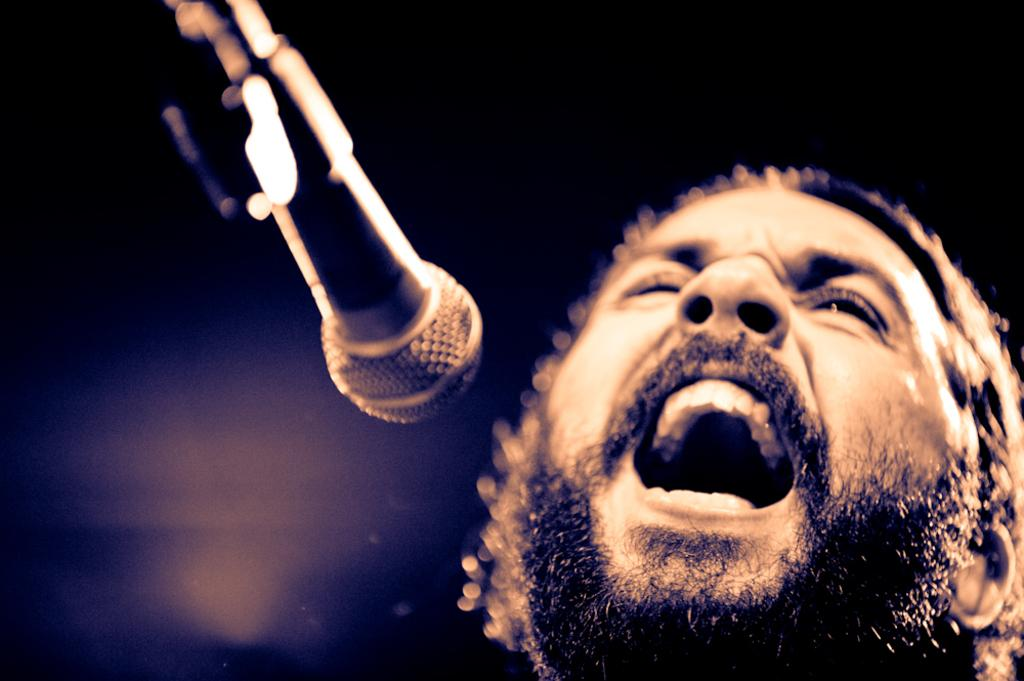What is the main subject of the image? There is a person in the image. What is the person doing in the image? The person is singing. What object is the person using while singing? The person is in front of a microphone. What can be observed about the lighting in the image? The background of the image is dark. How many people are in the crowd watching the person sing in the image? There is no crowd present in the image; it only shows a person singing in front of a microphone. What is the person's wish while singing in the image? There is no information about the person's wishes in the image; it only shows them singing in front of a microphone. 